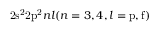<formula> <loc_0><loc_0><loc_500><loc_500>2 s ^ { 2 } 2 p ^ { 2 } n l ( n = 3 , 4 , l = p , f )</formula> 